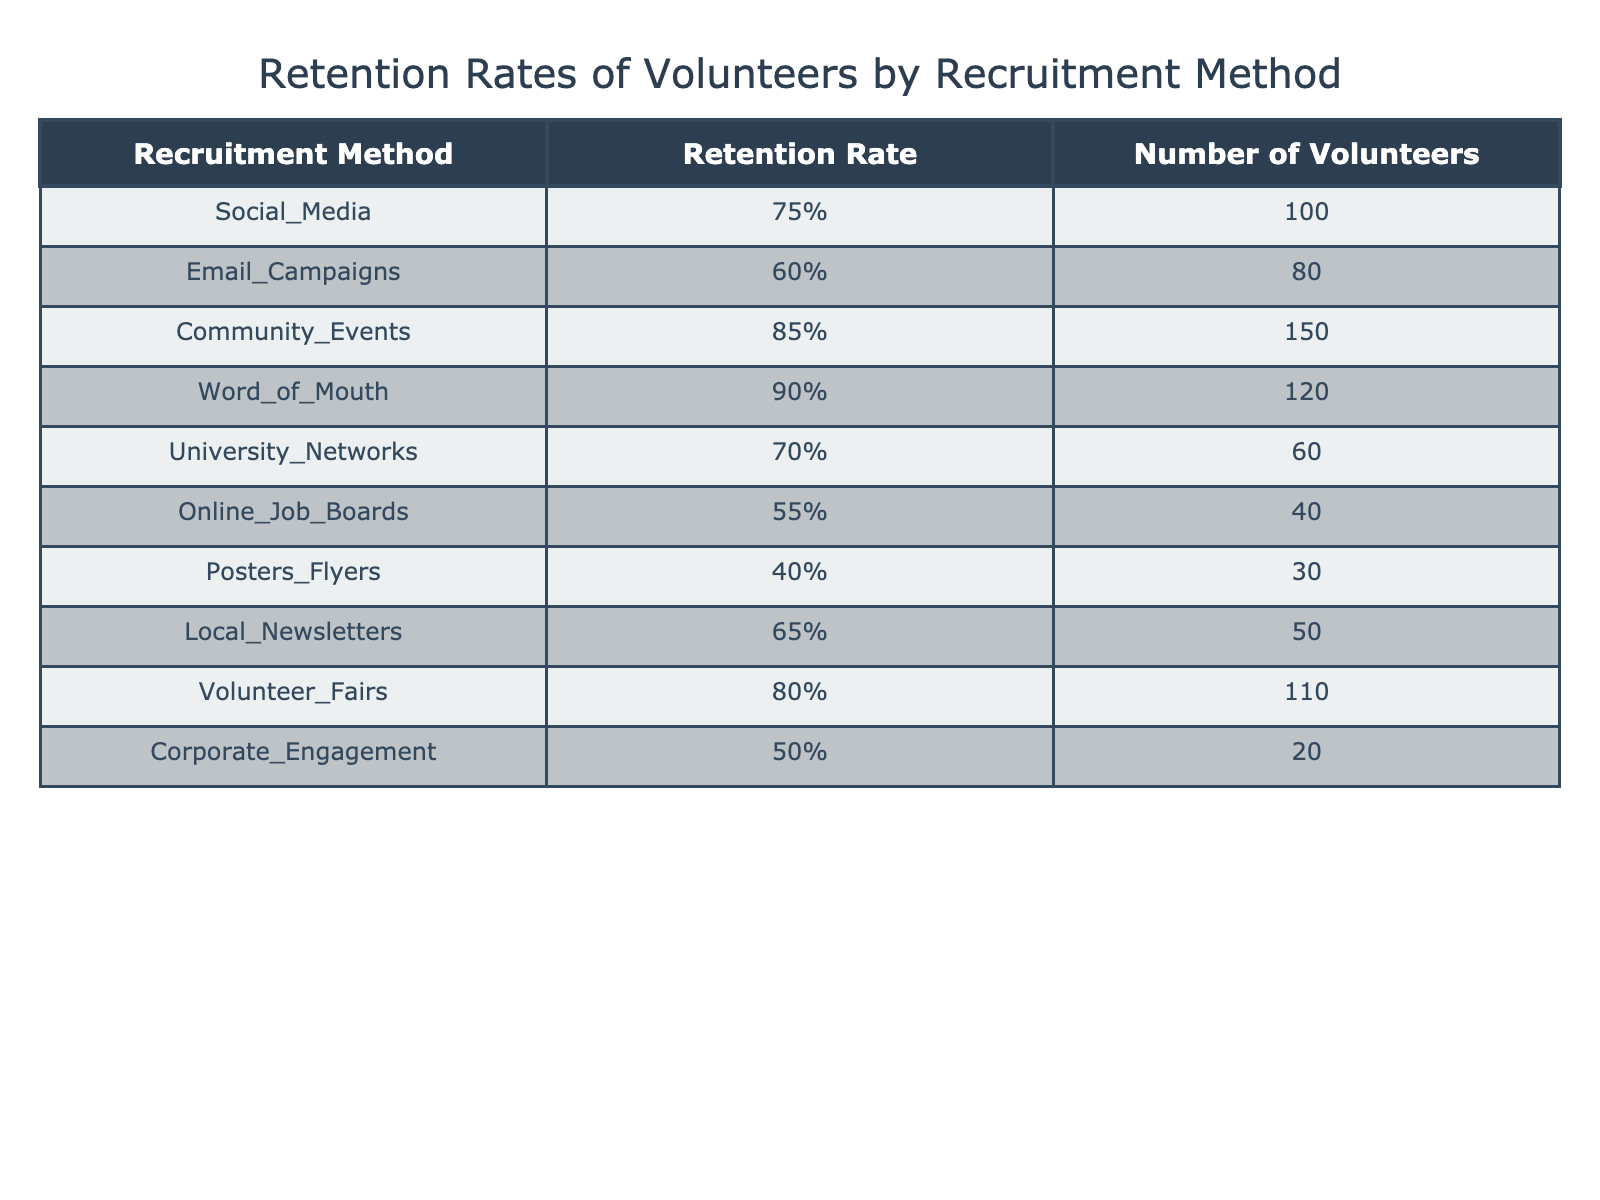What is the retention rate for the Word of Mouth recruitment method? The table shows the retention rates for each recruitment method. Looking for the row corresponding to "Word of Mouth," we find that the retention rate is 90%.
Answer: 90% How many volunteers were recruited through Community Events? In the table, the row for "Community Events" lists the number of volunteers as 150.
Answer: 150 Which recruitment method had the lowest retention rate, and what was that percentage? By examining the retention rates listed in the table, "Posters Flyers" has the lowest retention rate at 40%.
Answer: Posters Flyers, 40% What is the average retention rate of volunteers recruited through Social Media, Email Campaigns, and University Networks? We find the retention rates for the specified methods: Social Media (75%), Email Campaigns (60%), and University Networks (70%). We calculate the average as (75 + 60 + 70) / 3 = 205 / 3 = approximately 68.33%.
Answer: 68.33% Is it true that the retention rate for Online Job Boards is higher than that of Email Campaigns? Comparing the retention rates in the table, Online Job Boards has a retention rate of 55% and Email Campaigns has 60%. Since 55% is not higher than 60%, the statement is false.
Answer: No Which recruitment method has the highest number of volunteers, and what is that number? The row for "Community Events" shows the highest number of volunteers, which is 150.
Answer: Community Events, 150 What is the total number of volunteers recruited using Corporate Engagement and Online Job Boards combined? Looking at the numbers for Corporate Engagement (20) and Online Job Boards (40), we add them: 20 + 40 = 60.
Answer: 60 How much higher is the retention rate for Volunteer Fairs compared to Online Job Boards? The retention rate for Volunteer Fairs is 80%, and for Online Job Boards, it is 55%. We find the difference: 80 - 55 = 25.
Answer: 25 Which two recruitment methods had the same retention rate? By reviewing the retention rates in the table, we see that no two methods have the same retention rate. Each value is unique.
Answer: None 